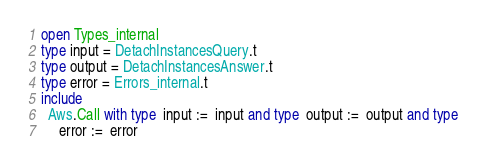Convert code to text. <code><loc_0><loc_0><loc_500><loc_500><_OCaml_>open Types_internal
type input = DetachInstancesQuery.t
type output = DetachInstancesAnswer.t
type error = Errors_internal.t
include
  Aws.Call with type  input :=  input and type  output :=  output and type
     error :=  error</code> 